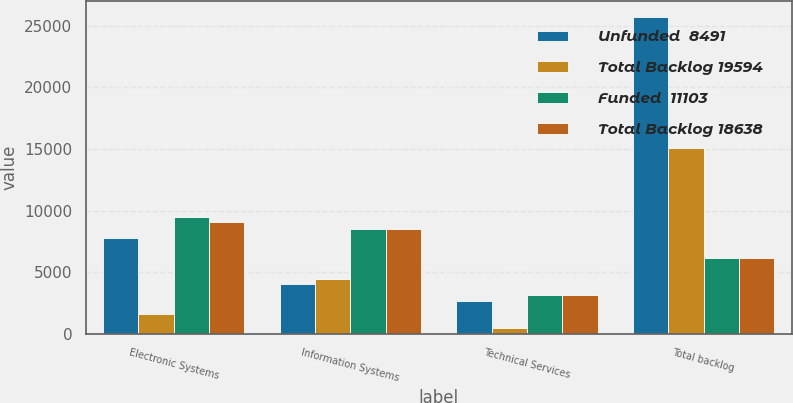<chart> <loc_0><loc_0><loc_500><loc_500><stacked_bar_chart><ecel><fcel>Electronic Systems<fcel>Information Systems<fcel>Technical Services<fcel>Total backlog<nl><fcel>Unfunded  8491<fcel>7833<fcel>4045<fcel>2719<fcel>25700<nl><fcel>Total Backlog 19594<fcel>1638<fcel>4496<fcel>484<fcel>15109<nl><fcel>Funded  11103<fcel>9471<fcel>8541<fcel>3203<fcel>6164.5<nl><fcel>Total Backlog 18638<fcel>9123<fcel>8563<fcel>3191<fcel>6164.5<nl></chart> 